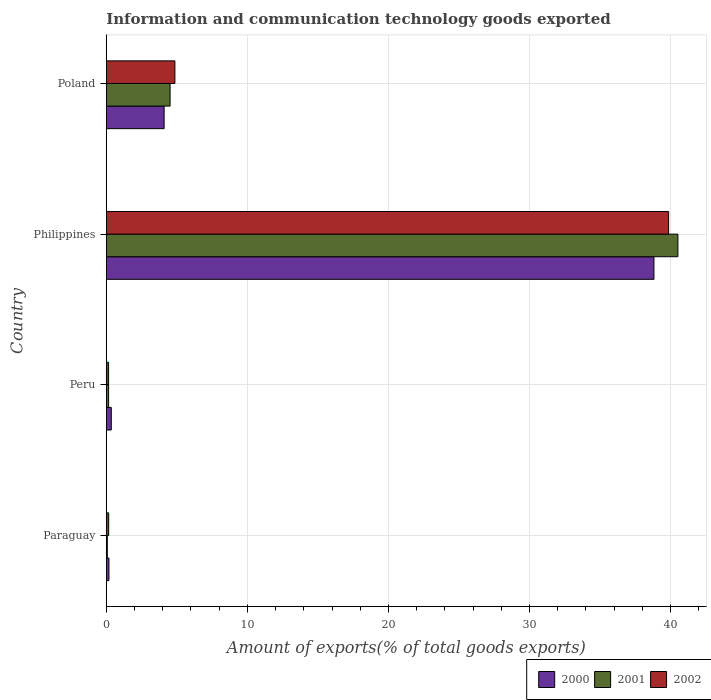Are the number of bars on each tick of the Y-axis equal?
Make the answer very short. Yes. How many bars are there on the 2nd tick from the top?
Ensure brevity in your answer.  3. How many bars are there on the 1st tick from the bottom?
Provide a succinct answer. 3. What is the amount of goods exported in 2002 in Peru?
Offer a very short reply. 0.16. Across all countries, what is the maximum amount of goods exported in 2002?
Ensure brevity in your answer.  39.86. Across all countries, what is the minimum amount of goods exported in 2001?
Your answer should be compact. 0.07. In which country was the amount of goods exported in 2000 minimum?
Your response must be concise. Paraguay. What is the total amount of goods exported in 2002 in the graph?
Keep it short and to the point. 45.05. What is the difference between the amount of goods exported in 2000 in Paraguay and that in Poland?
Give a very brief answer. -3.91. What is the difference between the amount of goods exported in 2002 in Poland and the amount of goods exported in 2001 in Paraguay?
Your answer should be compact. 4.79. What is the average amount of goods exported in 2000 per country?
Ensure brevity in your answer.  10.86. What is the difference between the amount of goods exported in 2000 and amount of goods exported in 2002 in Paraguay?
Give a very brief answer. 0.02. What is the ratio of the amount of goods exported in 2000 in Peru to that in Philippines?
Your answer should be compact. 0.01. Is the difference between the amount of goods exported in 2000 in Paraguay and Philippines greater than the difference between the amount of goods exported in 2002 in Paraguay and Philippines?
Provide a short and direct response. Yes. What is the difference between the highest and the second highest amount of goods exported in 2001?
Offer a terse response. 36. What is the difference between the highest and the lowest amount of goods exported in 2002?
Your answer should be very brief. 39.7. Is the sum of the amount of goods exported in 2002 in Peru and Philippines greater than the maximum amount of goods exported in 2000 across all countries?
Provide a short and direct response. Yes. What does the 2nd bar from the bottom in Paraguay represents?
Your answer should be compact. 2001. Is it the case that in every country, the sum of the amount of goods exported in 2000 and amount of goods exported in 2001 is greater than the amount of goods exported in 2002?
Provide a short and direct response. Yes. What is the difference between two consecutive major ticks on the X-axis?
Keep it short and to the point. 10. Are the values on the major ticks of X-axis written in scientific E-notation?
Ensure brevity in your answer.  No. Where does the legend appear in the graph?
Give a very brief answer. Bottom right. How many legend labels are there?
Your response must be concise. 3. What is the title of the graph?
Ensure brevity in your answer.  Information and communication technology goods exported. What is the label or title of the X-axis?
Ensure brevity in your answer.  Amount of exports(% of total goods exports). What is the label or title of the Y-axis?
Your answer should be very brief. Country. What is the Amount of exports(% of total goods exports) in 2000 in Paraguay?
Make the answer very short. 0.18. What is the Amount of exports(% of total goods exports) of 2001 in Paraguay?
Offer a terse response. 0.07. What is the Amount of exports(% of total goods exports) in 2002 in Paraguay?
Your response must be concise. 0.17. What is the Amount of exports(% of total goods exports) in 2000 in Peru?
Keep it short and to the point. 0.35. What is the Amount of exports(% of total goods exports) of 2001 in Peru?
Provide a succinct answer. 0.16. What is the Amount of exports(% of total goods exports) of 2002 in Peru?
Your answer should be very brief. 0.16. What is the Amount of exports(% of total goods exports) of 2000 in Philippines?
Offer a very short reply. 38.82. What is the Amount of exports(% of total goods exports) of 2001 in Philippines?
Give a very brief answer. 40.52. What is the Amount of exports(% of total goods exports) of 2002 in Philippines?
Your response must be concise. 39.86. What is the Amount of exports(% of total goods exports) in 2000 in Poland?
Your answer should be very brief. 4.1. What is the Amount of exports(% of total goods exports) in 2001 in Poland?
Give a very brief answer. 4.52. What is the Amount of exports(% of total goods exports) of 2002 in Poland?
Offer a very short reply. 4.86. Across all countries, what is the maximum Amount of exports(% of total goods exports) of 2000?
Give a very brief answer. 38.82. Across all countries, what is the maximum Amount of exports(% of total goods exports) in 2001?
Keep it short and to the point. 40.52. Across all countries, what is the maximum Amount of exports(% of total goods exports) of 2002?
Your answer should be compact. 39.86. Across all countries, what is the minimum Amount of exports(% of total goods exports) of 2000?
Provide a short and direct response. 0.18. Across all countries, what is the minimum Amount of exports(% of total goods exports) in 2001?
Your answer should be compact. 0.07. Across all countries, what is the minimum Amount of exports(% of total goods exports) in 2002?
Offer a terse response. 0.16. What is the total Amount of exports(% of total goods exports) of 2000 in the graph?
Ensure brevity in your answer.  43.45. What is the total Amount of exports(% of total goods exports) of 2001 in the graph?
Your answer should be compact. 45.27. What is the total Amount of exports(% of total goods exports) in 2002 in the graph?
Your answer should be very brief. 45.05. What is the difference between the Amount of exports(% of total goods exports) in 2000 in Paraguay and that in Peru?
Provide a short and direct response. -0.17. What is the difference between the Amount of exports(% of total goods exports) of 2001 in Paraguay and that in Peru?
Make the answer very short. -0.09. What is the difference between the Amount of exports(% of total goods exports) in 2002 in Paraguay and that in Peru?
Offer a very short reply. 0.01. What is the difference between the Amount of exports(% of total goods exports) in 2000 in Paraguay and that in Philippines?
Provide a short and direct response. -38.64. What is the difference between the Amount of exports(% of total goods exports) in 2001 in Paraguay and that in Philippines?
Your response must be concise. -40.45. What is the difference between the Amount of exports(% of total goods exports) of 2002 in Paraguay and that in Philippines?
Make the answer very short. -39.69. What is the difference between the Amount of exports(% of total goods exports) of 2000 in Paraguay and that in Poland?
Your response must be concise. -3.91. What is the difference between the Amount of exports(% of total goods exports) in 2001 in Paraguay and that in Poland?
Your answer should be very brief. -4.45. What is the difference between the Amount of exports(% of total goods exports) of 2002 in Paraguay and that in Poland?
Ensure brevity in your answer.  -4.69. What is the difference between the Amount of exports(% of total goods exports) of 2000 in Peru and that in Philippines?
Keep it short and to the point. -38.47. What is the difference between the Amount of exports(% of total goods exports) in 2001 in Peru and that in Philippines?
Offer a very short reply. -40.36. What is the difference between the Amount of exports(% of total goods exports) in 2002 in Peru and that in Philippines?
Your answer should be compact. -39.7. What is the difference between the Amount of exports(% of total goods exports) of 2000 in Peru and that in Poland?
Your answer should be very brief. -3.75. What is the difference between the Amount of exports(% of total goods exports) of 2001 in Peru and that in Poland?
Provide a short and direct response. -4.36. What is the difference between the Amount of exports(% of total goods exports) in 2002 in Peru and that in Poland?
Offer a terse response. -4.7. What is the difference between the Amount of exports(% of total goods exports) of 2000 in Philippines and that in Poland?
Keep it short and to the point. 34.72. What is the difference between the Amount of exports(% of total goods exports) of 2001 in Philippines and that in Poland?
Offer a terse response. 36. What is the difference between the Amount of exports(% of total goods exports) of 2002 in Philippines and that in Poland?
Ensure brevity in your answer.  35. What is the difference between the Amount of exports(% of total goods exports) in 2000 in Paraguay and the Amount of exports(% of total goods exports) in 2001 in Peru?
Offer a very short reply. 0.02. What is the difference between the Amount of exports(% of total goods exports) in 2000 in Paraguay and the Amount of exports(% of total goods exports) in 2002 in Peru?
Your answer should be compact. 0.02. What is the difference between the Amount of exports(% of total goods exports) of 2001 in Paraguay and the Amount of exports(% of total goods exports) of 2002 in Peru?
Offer a terse response. -0.09. What is the difference between the Amount of exports(% of total goods exports) in 2000 in Paraguay and the Amount of exports(% of total goods exports) in 2001 in Philippines?
Provide a succinct answer. -40.34. What is the difference between the Amount of exports(% of total goods exports) of 2000 in Paraguay and the Amount of exports(% of total goods exports) of 2002 in Philippines?
Your answer should be very brief. -39.68. What is the difference between the Amount of exports(% of total goods exports) of 2001 in Paraguay and the Amount of exports(% of total goods exports) of 2002 in Philippines?
Offer a terse response. -39.79. What is the difference between the Amount of exports(% of total goods exports) in 2000 in Paraguay and the Amount of exports(% of total goods exports) in 2001 in Poland?
Give a very brief answer. -4.33. What is the difference between the Amount of exports(% of total goods exports) in 2000 in Paraguay and the Amount of exports(% of total goods exports) in 2002 in Poland?
Your response must be concise. -4.68. What is the difference between the Amount of exports(% of total goods exports) of 2001 in Paraguay and the Amount of exports(% of total goods exports) of 2002 in Poland?
Provide a short and direct response. -4.79. What is the difference between the Amount of exports(% of total goods exports) in 2000 in Peru and the Amount of exports(% of total goods exports) in 2001 in Philippines?
Ensure brevity in your answer.  -40.17. What is the difference between the Amount of exports(% of total goods exports) of 2000 in Peru and the Amount of exports(% of total goods exports) of 2002 in Philippines?
Provide a succinct answer. -39.51. What is the difference between the Amount of exports(% of total goods exports) of 2001 in Peru and the Amount of exports(% of total goods exports) of 2002 in Philippines?
Keep it short and to the point. -39.7. What is the difference between the Amount of exports(% of total goods exports) of 2000 in Peru and the Amount of exports(% of total goods exports) of 2001 in Poland?
Your answer should be compact. -4.17. What is the difference between the Amount of exports(% of total goods exports) in 2000 in Peru and the Amount of exports(% of total goods exports) in 2002 in Poland?
Provide a succinct answer. -4.51. What is the difference between the Amount of exports(% of total goods exports) of 2001 in Peru and the Amount of exports(% of total goods exports) of 2002 in Poland?
Ensure brevity in your answer.  -4.7. What is the difference between the Amount of exports(% of total goods exports) in 2000 in Philippines and the Amount of exports(% of total goods exports) in 2001 in Poland?
Offer a very short reply. 34.3. What is the difference between the Amount of exports(% of total goods exports) in 2000 in Philippines and the Amount of exports(% of total goods exports) in 2002 in Poland?
Make the answer very short. 33.96. What is the difference between the Amount of exports(% of total goods exports) of 2001 in Philippines and the Amount of exports(% of total goods exports) of 2002 in Poland?
Make the answer very short. 35.66. What is the average Amount of exports(% of total goods exports) in 2000 per country?
Ensure brevity in your answer.  10.86. What is the average Amount of exports(% of total goods exports) of 2001 per country?
Ensure brevity in your answer.  11.32. What is the average Amount of exports(% of total goods exports) in 2002 per country?
Make the answer very short. 11.26. What is the difference between the Amount of exports(% of total goods exports) in 2000 and Amount of exports(% of total goods exports) in 2001 in Paraguay?
Provide a short and direct response. 0.12. What is the difference between the Amount of exports(% of total goods exports) in 2000 and Amount of exports(% of total goods exports) in 2002 in Paraguay?
Your answer should be compact. 0.02. What is the difference between the Amount of exports(% of total goods exports) in 2001 and Amount of exports(% of total goods exports) in 2002 in Paraguay?
Your response must be concise. -0.1. What is the difference between the Amount of exports(% of total goods exports) in 2000 and Amount of exports(% of total goods exports) in 2001 in Peru?
Offer a very short reply. 0.19. What is the difference between the Amount of exports(% of total goods exports) of 2000 and Amount of exports(% of total goods exports) of 2002 in Peru?
Provide a succinct answer. 0.19. What is the difference between the Amount of exports(% of total goods exports) in 2000 and Amount of exports(% of total goods exports) in 2001 in Philippines?
Your answer should be very brief. -1.7. What is the difference between the Amount of exports(% of total goods exports) in 2000 and Amount of exports(% of total goods exports) in 2002 in Philippines?
Your answer should be very brief. -1.04. What is the difference between the Amount of exports(% of total goods exports) in 2001 and Amount of exports(% of total goods exports) in 2002 in Philippines?
Offer a terse response. 0.66. What is the difference between the Amount of exports(% of total goods exports) of 2000 and Amount of exports(% of total goods exports) of 2001 in Poland?
Your answer should be compact. -0.42. What is the difference between the Amount of exports(% of total goods exports) in 2000 and Amount of exports(% of total goods exports) in 2002 in Poland?
Your response must be concise. -0.76. What is the difference between the Amount of exports(% of total goods exports) in 2001 and Amount of exports(% of total goods exports) in 2002 in Poland?
Your answer should be very brief. -0.34. What is the ratio of the Amount of exports(% of total goods exports) of 2000 in Paraguay to that in Peru?
Keep it short and to the point. 0.53. What is the ratio of the Amount of exports(% of total goods exports) in 2001 in Paraguay to that in Peru?
Your response must be concise. 0.43. What is the ratio of the Amount of exports(% of total goods exports) of 2002 in Paraguay to that in Peru?
Offer a terse response. 1.04. What is the ratio of the Amount of exports(% of total goods exports) in 2000 in Paraguay to that in Philippines?
Make the answer very short. 0. What is the ratio of the Amount of exports(% of total goods exports) in 2001 in Paraguay to that in Philippines?
Your response must be concise. 0. What is the ratio of the Amount of exports(% of total goods exports) in 2002 in Paraguay to that in Philippines?
Your answer should be compact. 0. What is the ratio of the Amount of exports(% of total goods exports) of 2000 in Paraguay to that in Poland?
Ensure brevity in your answer.  0.04. What is the ratio of the Amount of exports(% of total goods exports) in 2001 in Paraguay to that in Poland?
Give a very brief answer. 0.02. What is the ratio of the Amount of exports(% of total goods exports) of 2002 in Paraguay to that in Poland?
Offer a terse response. 0.03. What is the ratio of the Amount of exports(% of total goods exports) in 2000 in Peru to that in Philippines?
Make the answer very short. 0.01. What is the ratio of the Amount of exports(% of total goods exports) in 2001 in Peru to that in Philippines?
Keep it short and to the point. 0. What is the ratio of the Amount of exports(% of total goods exports) of 2002 in Peru to that in Philippines?
Provide a succinct answer. 0. What is the ratio of the Amount of exports(% of total goods exports) of 2000 in Peru to that in Poland?
Keep it short and to the point. 0.09. What is the ratio of the Amount of exports(% of total goods exports) of 2001 in Peru to that in Poland?
Your answer should be very brief. 0.04. What is the ratio of the Amount of exports(% of total goods exports) of 2002 in Peru to that in Poland?
Your answer should be compact. 0.03. What is the ratio of the Amount of exports(% of total goods exports) in 2000 in Philippines to that in Poland?
Make the answer very short. 9.48. What is the ratio of the Amount of exports(% of total goods exports) in 2001 in Philippines to that in Poland?
Your answer should be very brief. 8.97. What is the ratio of the Amount of exports(% of total goods exports) in 2002 in Philippines to that in Poland?
Offer a terse response. 8.2. What is the difference between the highest and the second highest Amount of exports(% of total goods exports) in 2000?
Offer a terse response. 34.72. What is the difference between the highest and the second highest Amount of exports(% of total goods exports) of 2001?
Offer a very short reply. 36. What is the difference between the highest and the second highest Amount of exports(% of total goods exports) of 2002?
Offer a very short reply. 35. What is the difference between the highest and the lowest Amount of exports(% of total goods exports) in 2000?
Your response must be concise. 38.64. What is the difference between the highest and the lowest Amount of exports(% of total goods exports) of 2001?
Keep it short and to the point. 40.45. What is the difference between the highest and the lowest Amount of exports(% of total goods exports) in 2002?
Your answer should be compact. 39.7. 